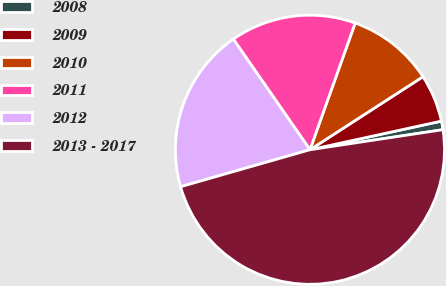Convert chart to OTSL. <chart><loc_0><loc_0><loc_500><loc_500><pie_chart><fcel>2008<fcel>2009<fcel>2010<fcel>2011<fcel>2012<fcel>2013 - 2017<nl><fcel>1.03%<fcel>5.72%<fcel>10.41%<fcel>15.1%<fcel>19.79%<fcel>47.95%<nl></chart> 